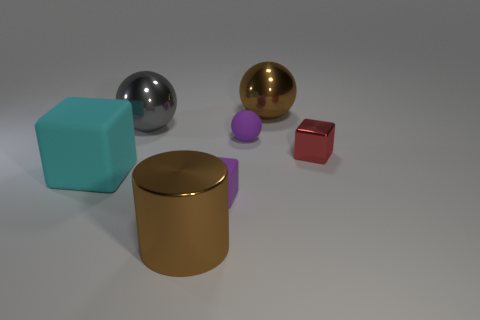Subtract 1 spheres. How many spheres are left? 2 Subtract all matte blocks. How many blocks are left? 1 Add 1 metallic cubes. How many objects exist? 8 Subtract all cylinders. How many objects are left? 6 Add 6 small rubber things. How many small rubber things are left? 8 Add 5 big cylinders. How many big cylinders exist? 6 Subtract 0 blue balls. How many objects are left? 7 Subtract all gray balls. Subtract all small purple metallic cubes. How many objects are left? 6 